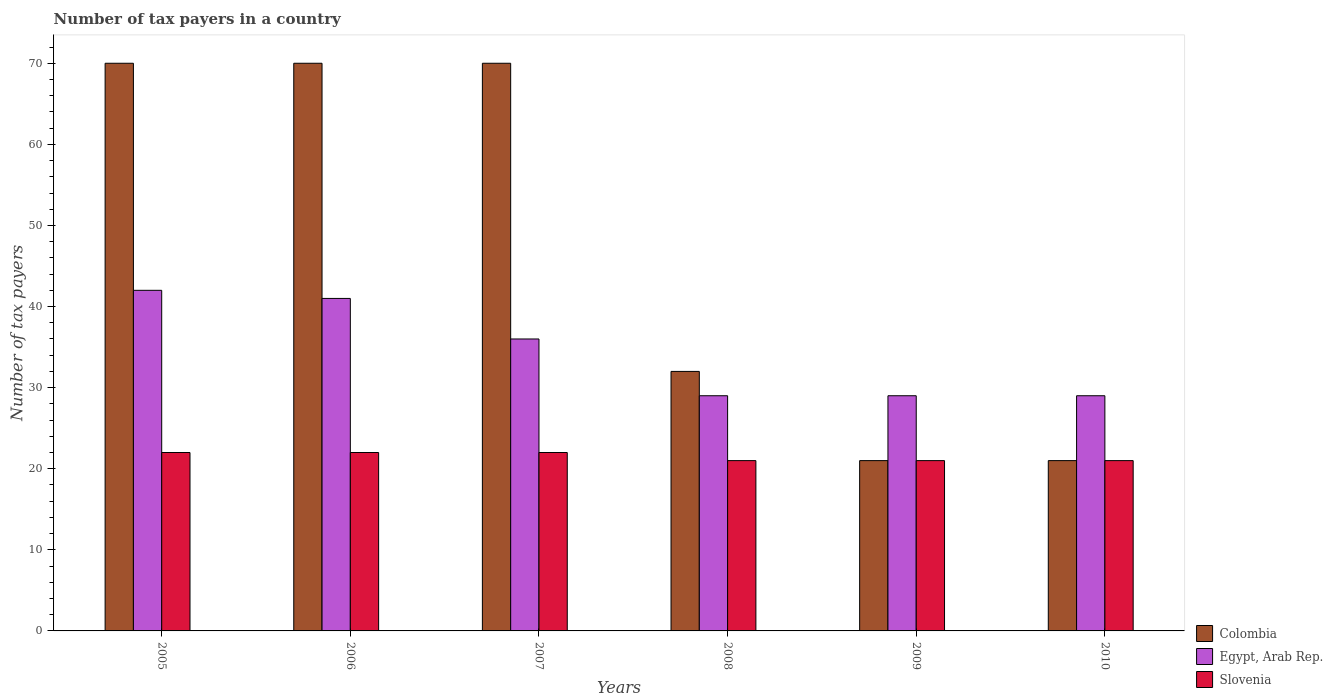How many different coloured bars are there?
Offer a very short reply. 3. How many groups of bars are there?
Your answer should be very brief. 6. Are the number of bars per tick equal to the number of legend labels?
Ensure brevity in your answer.  Yes. How many bars are there on the 5th tick from the left?
Offer a very short reply. 3. How many bars are there on the 3rd tick from the right?
Offer a terse response. 3. In how many cases, is the number of bars for a given year not equal to the number of legend labels?
Give a very brief answer. 0. What is the number of tax payers in in Egypt, Arab Rep. in 2010?
Offer a terse response. 29. Across all years, what is the maximum number of tax payers in in Slovenia?
Your answer should be very brief. 22. Across all years, what is the minimum number of tax payers in in Slovenia?
Provide a short and direct response. 21. In which year was the number of tax payers in in Slovenia maximum?
Provide a succinct answer. 2005. What is the total number of tax payers in in Slovenia in the graph?
Provide a succinct answer. 129. What is the difference between the number of tax payers in in Egypt, Arab Rep. in 2010 and the number of tax payers in in Slovenia in 2009?
Provide a short and direct response. 8. What is the average number of tax payers in in Colombia per year?
Provide a short and direct response. 47.33. In the year 2009, what is the difference between the number of tax payers in in Egypt, Arab Rep. and number of tax payers in in Slovenia?
Your answer should be compact. 8. In how many years, is the number of tax payers in in Egypt, Arab Rep. greater than 56?
Provide a succinct answer. 0. What is the ratio of the number of tax payers in in Slovenia in 2009 to that in 2010?
Ensure brevity in your answer.  1. Is the number of tax payers in in Slovenia in 2005 less than that in 2008?
Ensure brevity in your answer.  No. Is the difference between the number of tax payers in in Egypt, Arab Rep. in 2005 and 2009 greater than the difference between the number of tax payers in in Slovenia in 2005 and 2009?
Your answer should be very brief. Yes. What is the difference between the highest and the lowest number of tax payers in in Colombia?
Ensure brevity in your answer.  49. In how many years, is the number of tax payers in in Colombia greater than the average number of tax payers in in Colombia taken over all years?
Keep it short and to the point. 3. What does the 3rd bar from the left in 2006 represents?
Keep it short and to the point. Slovenia. What does the 2nd bar from the right in 2007 represents?
Your answer should be compact. Egypt, Arab Rep. Is it the case that in every year, the sum of the number of tax payers in in Slovenia and number of tax payers in in Egypt, Arab Rep. is greater than the number of tax payers in in Colombia?
Your answer should be compact. No. Are all the bars in the graph horizontal?
Make the answer very short. No. How many years are there in the graph?
Provide a succinct answer. 6. Are the values on the major ticks of Y-axis written in scientific E-notation?
Offer a very short reply. No. Does the graph contain grids?
Provide a short and direct response. No. How are the legend labels stacked?
Your answer should be very brief. Vertical. What is the title of the graph?
Your answer should be compact. Number of tax payers in a country. Does "Uruguay" appear as one of the legend labels in the graph?
Give a very brief answer. No. What is the label or title of the Y-axis?
Your answer should be compact. Number of tax payers. What is the Number of tax payers in Colombia in 2005?
Provide a short and direct response. 70. What is the Number of tax payers of Egypt, Arab Rep. in 2005?
Offer a terse response. 42. What is the Number of tax payers of Colombia in 2006?
Offer a very short reply. 70. What is the Number of tax payers in Egypt, Arab Rep. in 2006?
Make the answer very short. 41. What is the Number of tax payers of Slovenia in 2006?
Offer a very short reply. 22. What is the Number of tax payers of Colombia in 2007?
Keep it short and to the point. 70. What is the Number of tax payers of Slovenia in 2007?
Your response must be concise. 22. What is the Number of tax payers in Colombia in 2008?
Offer a terse response. 32. What is the Number of tax payers in Egypt, Arab Rep. in 2008?
Keep it short and to the point. 29. What is the Number of tax payers in Slovenia in 2009?
Your answer should be very brief. 21. What is the Number of tax payers of Egypt, Arab Rep. in 2010?
Keep it short and to the point. 29. What is the Number of tax payers of Slovenia in 2010?
Provide a short and direct response. 21. Across all years, what is the maximum Number of tax payers in Colombia?
Offer a terse response. 70. Across all years, what is the maximum Number of tax payers in Egypt, Arab Rep.?
Provide a succinct answer. 42. Across all years, what is the maximum Number of tax payers in Slovenia?
Offer a very short reply. 22. Across all years, what is the minimum Number of tax payers in Slovenia?
Ensure brevity in your answer.  21. What is the total Number of tax payers in Colombia in the graph?
Provide a succinct answer. 284. What is the total Number of tax payers in Egypt, Arab Rep. in the graph?
Your answer should be very brief. 206. What is the total Number of tax payers in Slovenia in the graph?
Offer a very short reply. 129. What is the difference between the Number of tax payers of Colombia in 2005 and that in 2006?
Provide a short and direct response. 0. What is the difference between the Number of tax payers in Egypt, Arab Rep. in 2005 and that in 2007?
Make the answer very short. 6. What is the difference between the Number of tax payers of Slovenia in 2005 and that in 2008?
Your answer should be very brief. 1. What is the difference between the Number of tax payers of Slovenia in 2005 and that in 2009?
Make the answer very short. 1. What is the difference between the Number of tax payers of Egypt, Arab Rep. in 2005 and that in 2010?
Your answer should be compact. 13. What is the difference between the Number of tax payers in Slovenia in 2005 and that in 2010?
Offer a very short reply. 1. What is the difference between the Number of tax payers in Colombia in 2006 and that in 2007?
Your answer should be compact. 0. What is the difference between the Number of tax payers in Egypt, Arab Rep. in 2006 and that in 2008?
Give a very brief answer. 12. What is the difference between the Number of tax payers in Slovenia in 2006 and that in 2008?
Ensure brevity in your answer.  1. What is the difference between the Number of tax payers in Egypt, Arab Rep. in 2006 and that in 2009?
Offer a very short reply. 12. What is the difference between the Number of tax payers in Slovenia in 2006 and that in 2009?
Offer a very short reply. 1. What is the difference between the Number of tax payers in Egypt, Arab Rep. in 2007 and that in 2009?
Keep it short and to the point. 7. What is the difference between the Number of tax payers of Colombia in 2007 and that in 2010?
Give a very brief answer. 49. What is the difference between the Number of tax payers of Egypt, Arab Rep. in 2007 and that in 2010?
Ensure brevity in your answer.  7. What is the difference between the Number of tax payers in Egypt, Arab Rep. in 2008 and that in 2009?
Offer a very short reply. 0. What is the difference between the Number of tax payers of Slovenia in 2008 and that in 2009?
Your answer should be compact. 0. What is the difference between the Number of tax payers in Colombia in 2008 and that in 2010?
Provide a short and direct response. 11. What is the difference between the Number of tax payers in Egypt, Arab Rep. in 2009 and that in 2010?
Ensure brevity in your answer.  0. What is the difference between the Number of tax payers of Slovenia in 2009 and that in 2010?
Provide a succinct answer. 0. What is the difference between the Number of tax payers in Colombia in 2005 and the Number of tax payers in Egypt, Arab Rep. in 2006?
Ensure brevity in your answer.  29. What is the difference between the Number of tax payers of Colombia in 2005 and the Number of tax payers of Slovenia in 2006?
Offer a terse response. 48. What is the difference between the Number of tax payers of Egypt, Arab Rep. in 2005 and the Number of tax payers of Slovenia in 2006?
Make the answer very short. 20. What is the difference between the Number of tax payers of Colombia in 2005 and the Number of tax payers of Egypt, Arab Rep. in 2007?
Keep it short and to the point. 34. What is the difference between the Number of tax payers in Egypt, Arab Rep. in 2005 and the Number of tax payers in Slovenia in 2007?
Make the answer very short. 20. What is the difference between the Number of tax payers in Colombia in 2005 and the Number of tax payers in Slovenia in 2009?
Your response must be concise. 49. What is the difference between the Number of tax payers in Egypt, Arab Rep. in 2005 and the Number of tax payers in Slovenia in 2009?
Provide a short and direct response. 21. What is the difference between the Number of tax payers in Colombia in 2005 and the Number of tax payers in Egypt, Arab Rep. in 2010?
Provide a succinct answer. 41. What is the difference between the Number of tax payers in Colombia in 2005 and the Number of tax payers in Slovenia in 2010?
Provide a succinct answer. 49. What is the difference between the Number of tax payers of Egypt, Arab Rep. in 2005 and the Number of tax payers of Slovenia in 2010?
Your answer should be compact. 21. What is the difference between the Number of tax payers in Colombia in 2006 and the Number of tax payers in Slovenia in 2007?
Your answer should be compact. 48. What is the difference between the Number of tax payers in Colombia in 2006 and the Number of tax payers in Slovenia in 2009?
Your answer should be compact. 49. What is the difference between the Number of tax payers in Egypt, Arab Rep. in 2006 and the Number of tax payers in Slovenia in 2009?
Provide a short and direct response. 20. What is the difference between the Number of tax payers of Egypt, Arab Rep. in 2006 and the Number of tax payers of Slovenia in 2010?
Give a very brief answer. 20. What is the difference between the Number of tax payers of Colombia in 2007 and the Number of tax payers of Egypt, Arab Rep. in 2008?
Ensure brevity in your answer.  41. What is the difference between the Number of tax payers of Egypt, Arab Rep. in 2007 and the Number of tax payers of Slovenia in 2008?
Give a very brief answer. 15. What is the difference between the Number of tax payers in Colombia in 2008 and the Number of tax payers in Egypt, Arab Rep. in 2009?
Keep it short and to the point. 3. What is the difference between the Number of tax payers of Egypt, Arab Rep. in 2008 and the Number of tax payers of Slovenia in 2009?
Your answer should be very brief. 8. What is the difference between the Number of tax payers of Colombia in 2008 and the Number of tax payers of Egypt, Arab Rep. in 2010?
Your answer should be compact. 3. What is the difference between the Number of tax payers in Colombia in 2008 and the Number of tax payers in Slovenia in 2010?
Ensure brevity in your answer.  11. What is the difference between the Number of tax payers in Egypt, Arab Rep. in 2008 and the Number of tax payers in Slovenia in 2010?
Your answer should be very brief. 8. What is the difference between the Number of tax payers of Colombia in 2009 and the Number of tax payers of Slovenia in 2010?
Offer a terse response. 0. What is the average Number of tax payers of Colombia per year?
Your response must be concise. 47.33. What is the average Number of tax payers of Egypt, Arab Rep. per year?
Offer a terse response. 34.33. In the year 2005, what is the difference between the Number of tax payers of Colombia and Number of tax payers of Egypt, Arab Rep.?
Your answer should be very brief. 28. In the year 2005, what is the difference between the Number of tax payers of Colombia and Number of tax payers of Slovenia?
Make the answer very short. 48. In the year 2007, what is the difference between the Number of tax payers in Egypt, Arab Rep. and Number of tax payers in Slovenia?
Make the answer very short. 14. In the year 2009, what is the difference between the Number of tax payers in Colombia and Number of tax payers in Egypt, Arab Rep.?
Give a very brief answer. -8. In the year 2009, what is the difference between the Number of tax payers in Colombia and Number of tax payers in Slovenia?
Provide a short and direct response. 0. In the year 2009, what is the difference between the Number of tax payers in Egypt, Arab Rep. and Number of tax payers in Slovenia?
Provide a succinct answer. 8. In the year 2010, what is the difference between the Number of tax payers of Colombia and Number of tax payers of Slovenia?
Ensure brevity in your answer.  0. What is the ratio of the Number of tax payers in Egypt, Arab Rep. in 2005 to that in 2006?
Make the answer very short. 1.02. What is the ratio of the Number of tax payers of Slovenia in 2005 to that in 2006?
Provide a succinct answer. 1. What is the ratio of the Number of tax payers of Colombia in 2005 to that in 2008?
Provide a succinct answer. 2.19. What is the ratio of the Number of tax payers of Egypt, Arab Rep. in 2005 to that in 2008?
Offer a very short reply. 1.45. What is the ratio of the Number of tax payers in Slovenia in 2005 to that in 2008?
Ensure brevity in your answer.  1.05. What is the ratio of the Number of tax payers of Egypt, Arab Rep. in 2005 to that in 2009?
Provide a succinct answer. 1.45. What is the ratio of the Number of tax payers in Slovenia in 2005 to that in 2009?
Provide a short and direct response. 1.05. What is the ratio of the Number of tax payers of Colombia in 2005 to that in 2010?
Your response must be concise. 3.33. What is the ratio of the Number of tax payers in Egypt, Arab Rep. in 2005 to that in 2010?
Your response must be concise. 1.45. What is the ratio of the Number of tax payers of Slovenia in 2005 to that in 2010?
Give a very brief answer. 1.05. What is the ratio of the Number of tax payers in Colombia in 2006 to that in 2007?
Make the answer very short. 1. What is the ratio of the Number of tax payers in Egypt, Arab Rep. in 2006 to that in 2007?
Provide a short and direct response. 1.14. What is the ratio of the Number of tax payers in Slovenia in 2006 to that in 2007?
Provide a succinct answer. 1. What is the ratio of the Number of tax payers in Colombia in 2006 to that in 2008?
Your answer should be very brief. 2.19. What is the ratio of the Number of tax payers of Egypt, Arab Rep. in 2006 to that in 2008?
Offer a terse response. 1.41. What is the ratio of the Number of tax payers of Slovenia in 2006 to that in 2008?
Offer a terse response. 1.05. What is the ratio of the Number of tax payers in Colombia in 2006 to that in 2009?
Make the answer very short. 3.33. What is the ratio of the Number of tax payers in Egypt, Arab Rep. in 2006 to that in 2009?
Offer a very short reply. 1.41. What is the ratio of the Number of tax payers of Slovenia in 2006 to that in 2009?
Provide a short and direct response. 1.05. What is the ratio of the Number of tax payers of Egypt, Arab Rep. in 2006 to that in 2010?
Your answer should be very brief. 1.41. What is the ratio of the Number of tax payers of Slovenia in 2006 to that in 2010?
Provide a short and direct response. 1.05. What is the ratio of the Number of tax payers of Colombia in 2007 to that in 2008?
Provide a short and direct response. 2.19. What is the ratio of the Number of tax payers in Egypt, Arab Rep. in 2007 to that in 2008?
Provide a succinct answer. 1.24. What is the ratio of the Number of tax payers of Slovenia in 2007 to that in 2008?
Offer a very short reply. 1.05. What is the ratio of the Number of tax payers in Colombia in 2007 to that in 2009?
Provide a succinct answer. 3.33. What is the ratio of the Number of tax payers of Egypt, Arab Rep. in 2007 to that in 2009?
Keep it short and to the point. 1.24. What is the ratio of the Number of tax payers of Slovenia in 2007 to that in 2009?
Your response must be concise. 1.05. What is the ratio of the Number of tax payers in Egypt, Arab Rep. in 2007 to that in 2010?
Your answer should be very brief. 1.24. What is the ratio of the Number of tax payers in Slovenia in 2007 to that in 2010?
Provide a succinct answer. 1.05. What is the ratio of the Number of tax payers in Colombia in 2008 to that in 2009?
Make the answer very short. 1.52. What is the ratio of the Number of tax payers of Slovenia in 2008 to that in 2009?
Give a very brief answer. 1. What is the ratio of the Number of tax payers in Colombia in 2008 to that in 2010?
Your answer should be compact. 1.52. What is the ratio of the Number of tax payers of Slovenia in 2008 to that in 2010?
Ensure brevity in your answer.  1. What is the difference between the highest and the second highest Number of tax payers in Egypt, Arab Rep.?
Provide a succinct answer. 1. What is the difference between the highest and the second highest Number of tax payers in Slovenia?
Provide a succinct answer. 0. What is the difference between the highest and the lowest Number of tax payers of Colombia?
Your answer should be compact. 49. What is the difference between the highest and the lowest Number of tax payers of Slovenia?
Give a very brief answer. 1. 